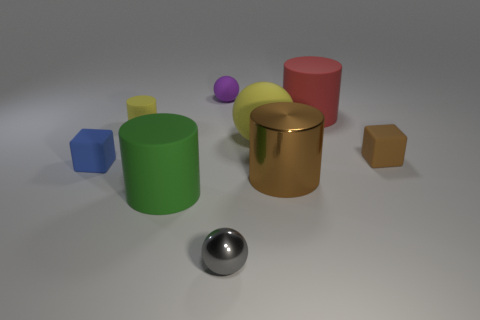The lighting in the scene has a soft quality. Can you describe the possible lighting setup used here? The soft shadows and lack of harsh highlights suggest a diffuse lighting setup, possibly from multiple light sources or a larger light source at a distance, such as a softbox or a window with natural daylight. 